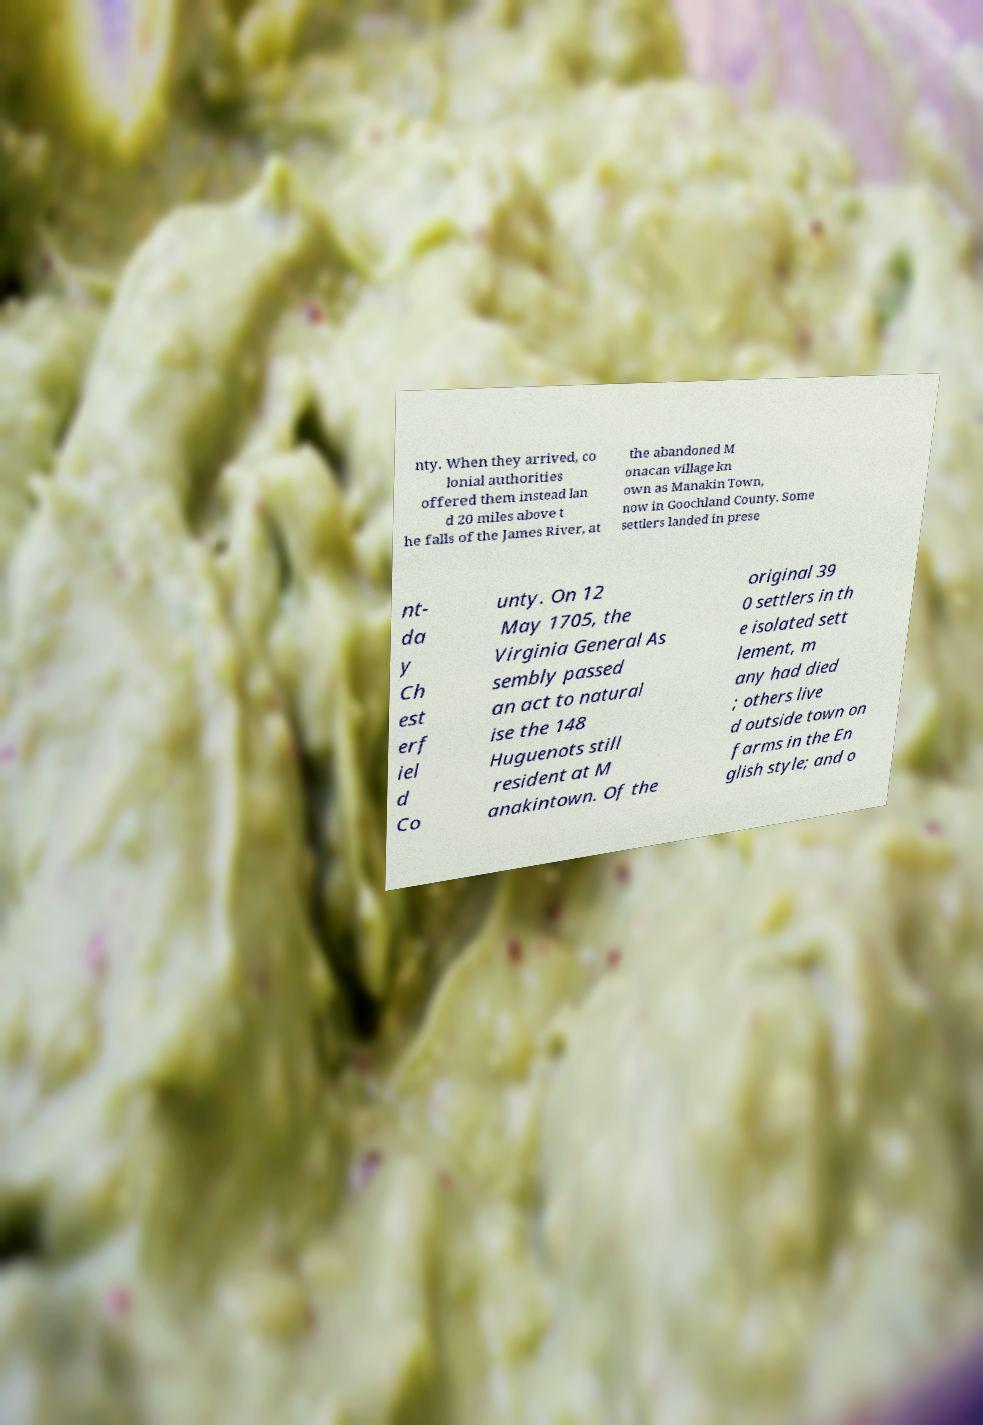What messages or text are displayed in this image? I need them in a readable, typed format. nty. When they arrived, co lonial authorities offered them instead lan d 20 miles above t he falls of the James River, at the abandoned M onacan village kn own as Manakin Town, now in Goochland County. Some settlers landed in prese nt- da y Ch est erf iel d Co unty. On 12 May 1705, the Virginia General As sembly passed an act to natural ise the 148 Huguenots still resident at M anakintown. Of the original 39 0 settlers in th e isolated sett lement, m any had died ; others live d outside town on farms in the En glish style; and o 